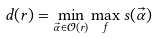<formula> <loc_0><loc_0><loc_500><loc_500>d ( r ) = \min _ { \vec { \alpha } \in \mathcal { O } ( r ) } \max _ { f } s ( \vec { \alpha } )</formula> 